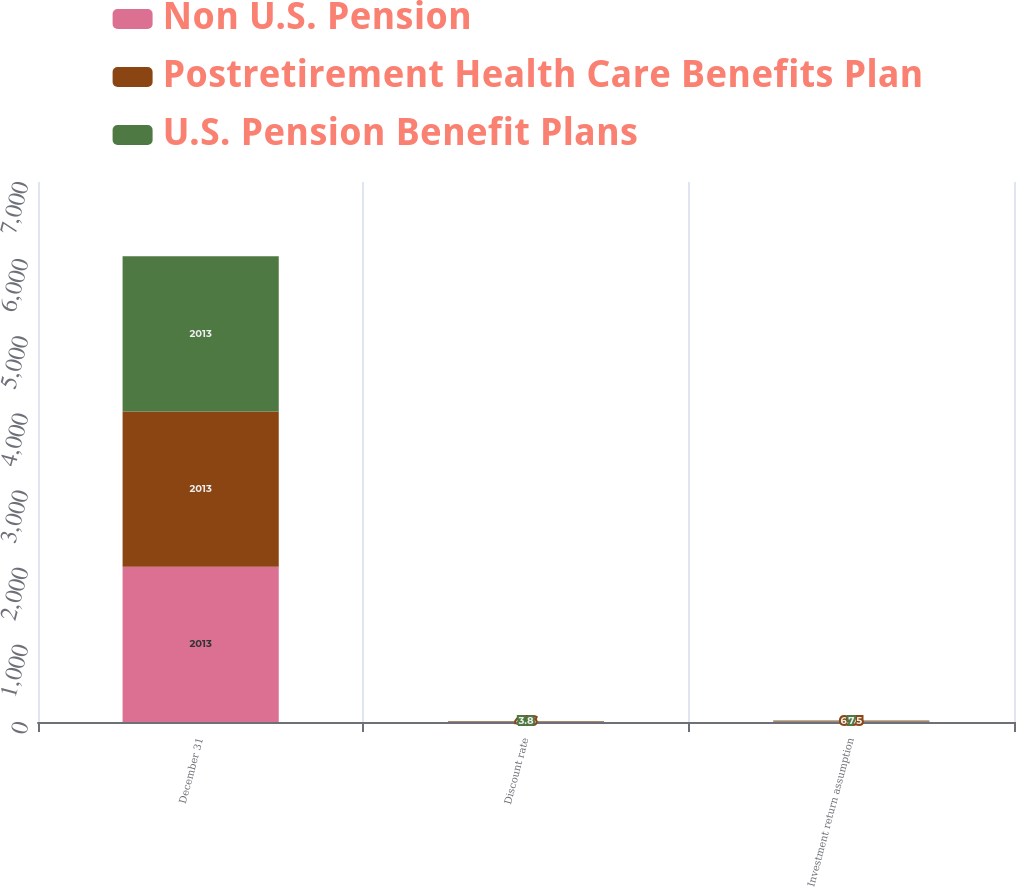Convert chart. <chart><loc_0><loc_0><loc_500><loc_500><stacked_bar_chart><ecel><fcel>December 31<fcel>Discount rate<fcel>Investment return assumption<nl><fcel>Non U.S. Pension<fcel>2013<fcel>4.35<fcel>7<nl><fcel>Postretirement Health Care Benefits Plan<fcel>2013<fcel>4.16<fcel>6.05<nl><fcel>U.S. Pension Benefit Plans<fcel>2013<fcel>3.8<fcel>7<nl></chart> 